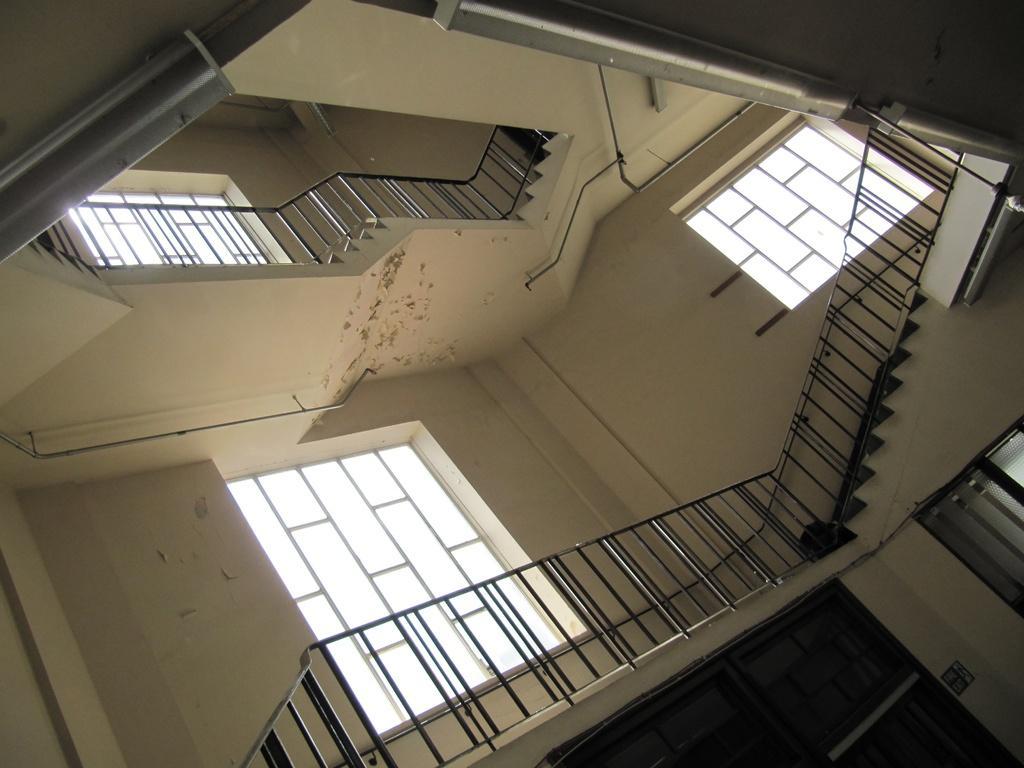Please provide a concise description of this image. In this image we can see a inside view of a building. In the background we can see staircase ,windows and some poles. 